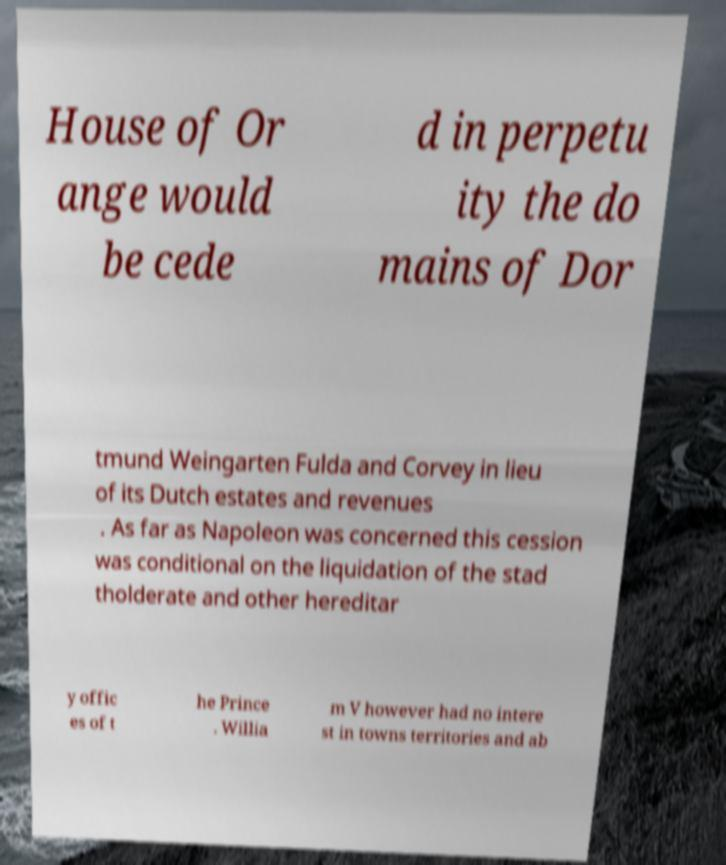Please identify and transcribe the text found in this image. House of Or ange would be cede d in perpetu ity the do mains of Dor tmund Weingarten Fulda and Corvey in lieu of its Dutch estates and revenues . As far as Napoleon was concerned this cession was conditional on the liquidation of the stad tholderate and other hereditar y offic es of t he Prince . Willia m V however had no intere st in towns territories and ab 